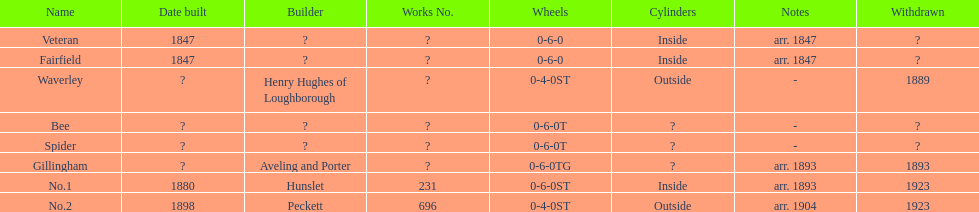What is the aggregate number of names on the chart? 8. 